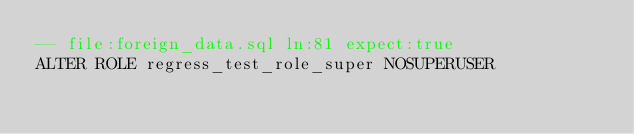Convert code to text. <code><loc_0><loc_0><loc_500><loc_500><_SQL_>-- file:foreign_data.sql ln:81 expect:true
ALTER ROLE regress_test_role_super NOSUPERUSER
</code> 